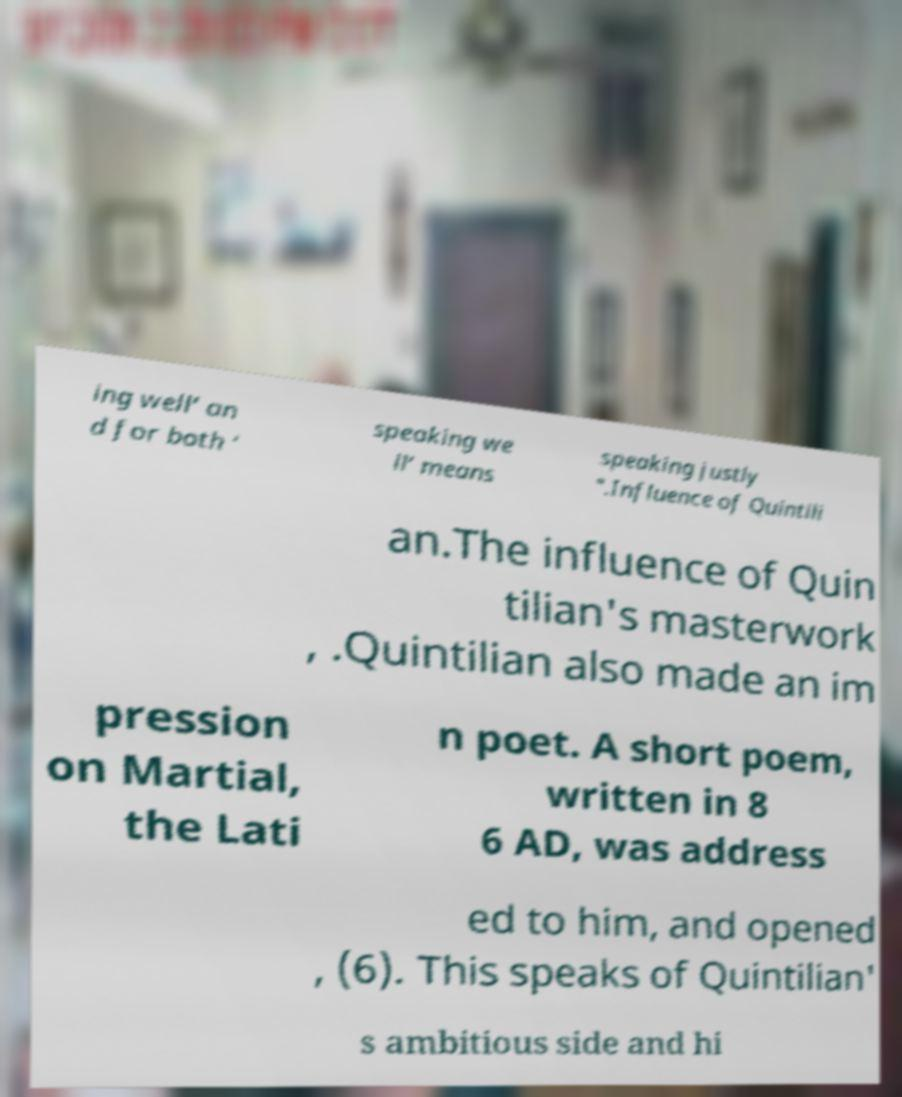There's text embedded in this image that I need extracted. Can you transcribe it verbatim? ing well’ an d for both ‘ speaking we ll’ means speaking justly ".Influence of Quintili an.The influence of Quin tilian's masterwork , .Quintilian also made an im pression on Martial, the Lati n poet. A short poem, written in 8 6 AD, was address ed to him, and opened , (6). This speaks of Quintilian' s ambitious side and hi 